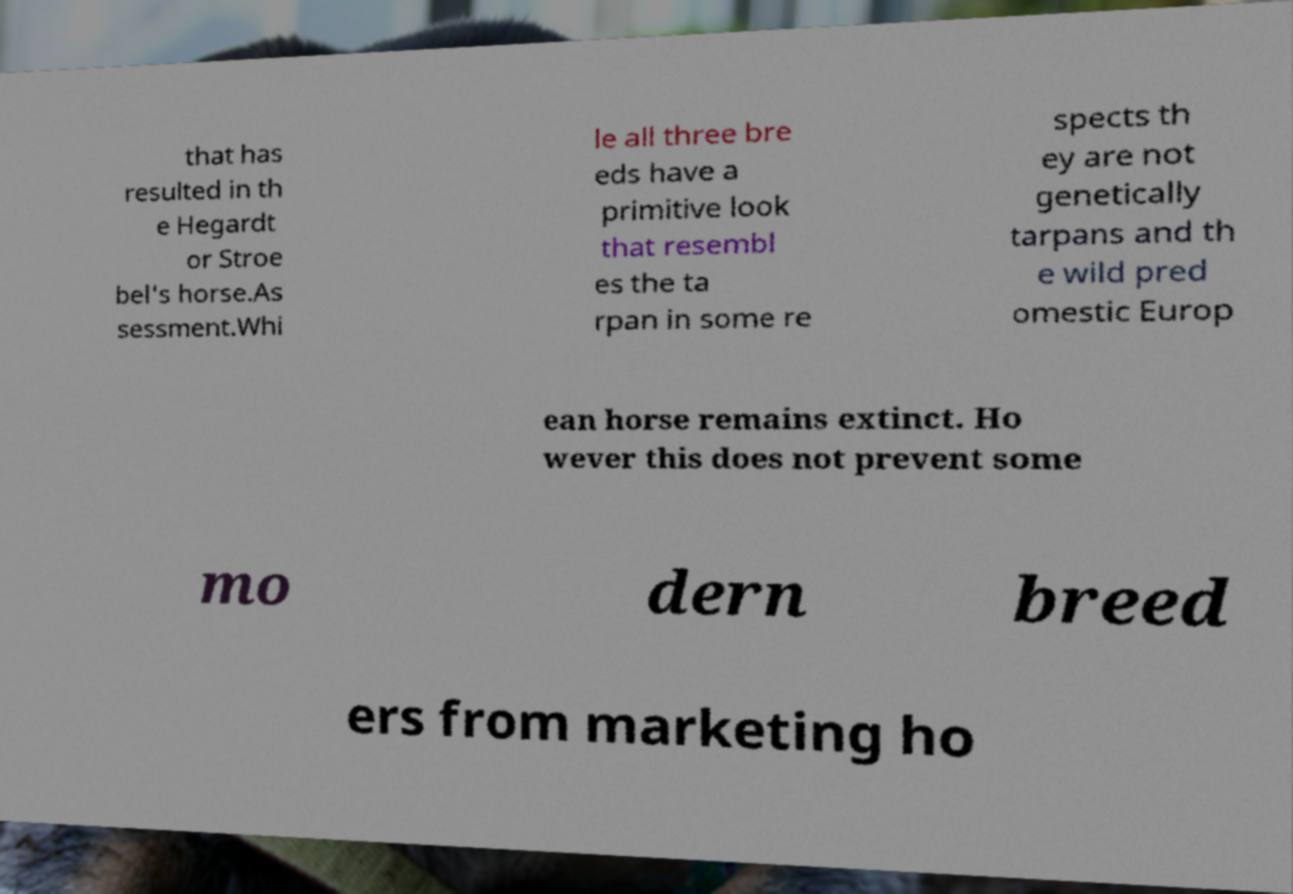What messages or text are displayed in this image? I need them in a readable, typed format. that has resulted in th e Hegardt or Stroe bel's horse.As sessment.Whi le all three bre eds have a primitive look that resembl es the ta rpan in some re spects th ey are not genetically tarpans and th e wild pred omestic Europ ean horse remains extinct. Ho wever this does not prevent some mo dern breed ers from marketing ho 